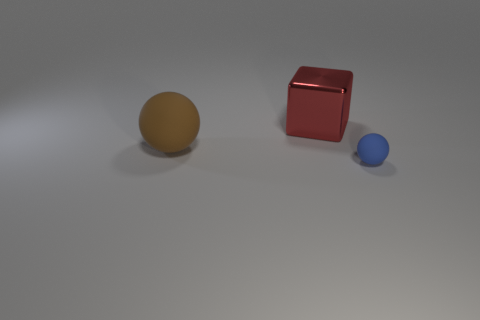What material is the big object behind the ball behind the matte sphere in front of the brown rubber object?
Keep it short and to the point. Metal. Is the number of tiny blue rubber spheres left of the large rubber sphere the same as the number of cubes?
Make the answer very short. No. Are there any other things that have the same size as the brown object?
Your response must be concise. Yes. How many things are either large blue things or large red cubes?
Offer a very short reply. 1. What shape is the thing that is made of the same material as the small blue ball?
Keep it short and to the point. Sphere. There is a rubber ball behind the small rubber ball in front of the large brown sphere; what is its size?
Your answer should be compact. Large. What number of big objects are brown metallic spheres or blue things?
Your answer should be very brief. 0. There is a sphere that is on the right side of the large red metal cube; is it the same size as the rubber thing to the left of the red object?
Keep it short and to the point. No. Does the brown object have the same material as the thing that is on the right side of the cube?
Your response must be concise. Yes. Are there more tiny rubber objects that are in front of the red block than large cubes that are in front of the blue sphere?
Ensure brevity in your answer.  Yes. 